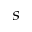<formula> <loc_0><loc_0><loc_500><loc_500>_ { s }</formula> 